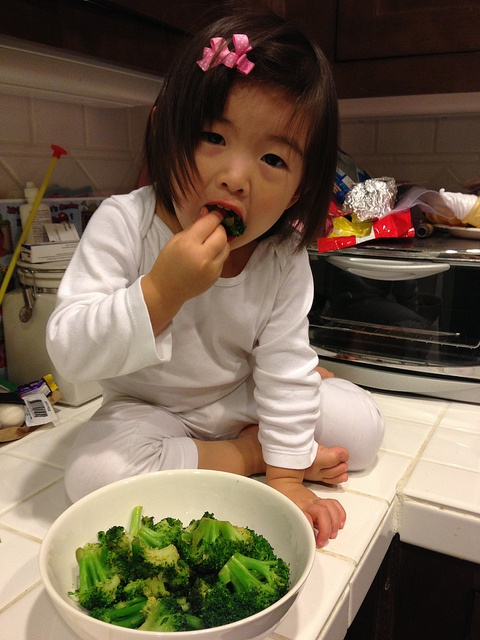Describe the objects in this image and their specific colors. I can see people in black, darkgray, lightgray, and gray tones, bowl in black, tan, and darkgreen tones, microwave in black, darkgray, and gray tones, and broccoli in black, darkgreen, and olive tones in this image. 